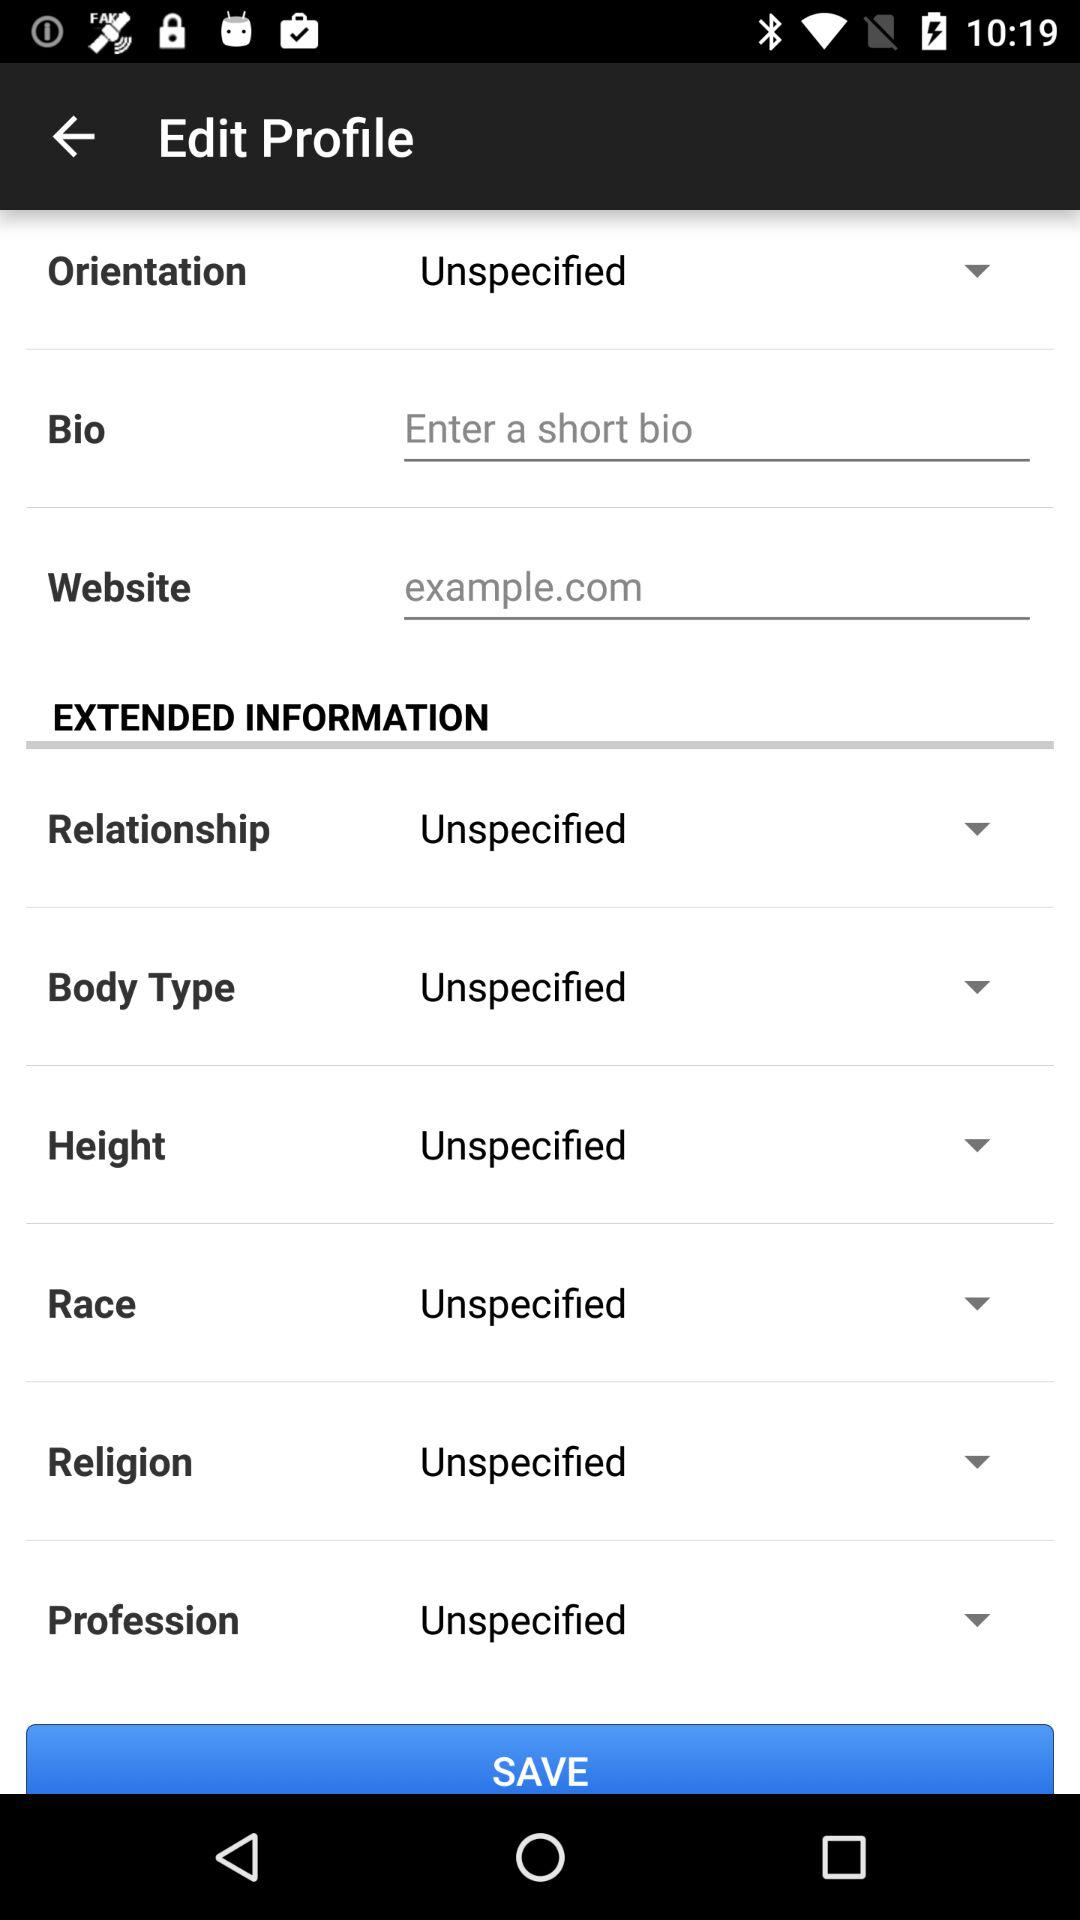What is the orientation? The orientation is "Unspecified". 